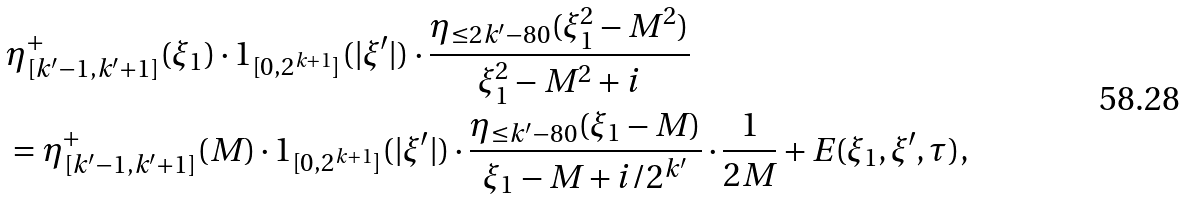Convert formula to latex. <formula><loc_0><loc_0><loc_500><loc_500>& \eta ^ { + } _ { [ k ^ { \prime } - 1 , k ^ { \prime } + 1 ] } ( \xi _ { 1 } ) \cdot 1 _ { [ 0 , 2 ^ { k + 1 } ] } ( | \xi ^ { \prime } | ) \cdot \frac { \eta _ { \leq 2 k ^ { \prime } - 8 0 } ( \xi _ { 1 } ^ { 2 } - M ^ { 2 } ) } { \xi _ { 1 } ^ { 2 } - M ^ { 2 } + i } \\ & = \eta ^ { + } _ { [ k ^ { \prime } - 1 , k ^ { \prime } + 1 ] } ( M ) \cdot 1 _ { [ 0 , 2 ^ { k + 1 } ] } ( | \xi ^ { \prime } | ) \cdot \frac { \eta _ { \leq k ^ { \prime } - 8 0 } ( \xi _ { 1 } - M ) } { \xi _ { 1 } - M + i / 2 ^ { k ^ { \prime } } } \cdot \frac { 1 } { 2 M } + E ( \xi _ { 1 } , \xi ^ { \prime } , \tau ) ,</formula> 